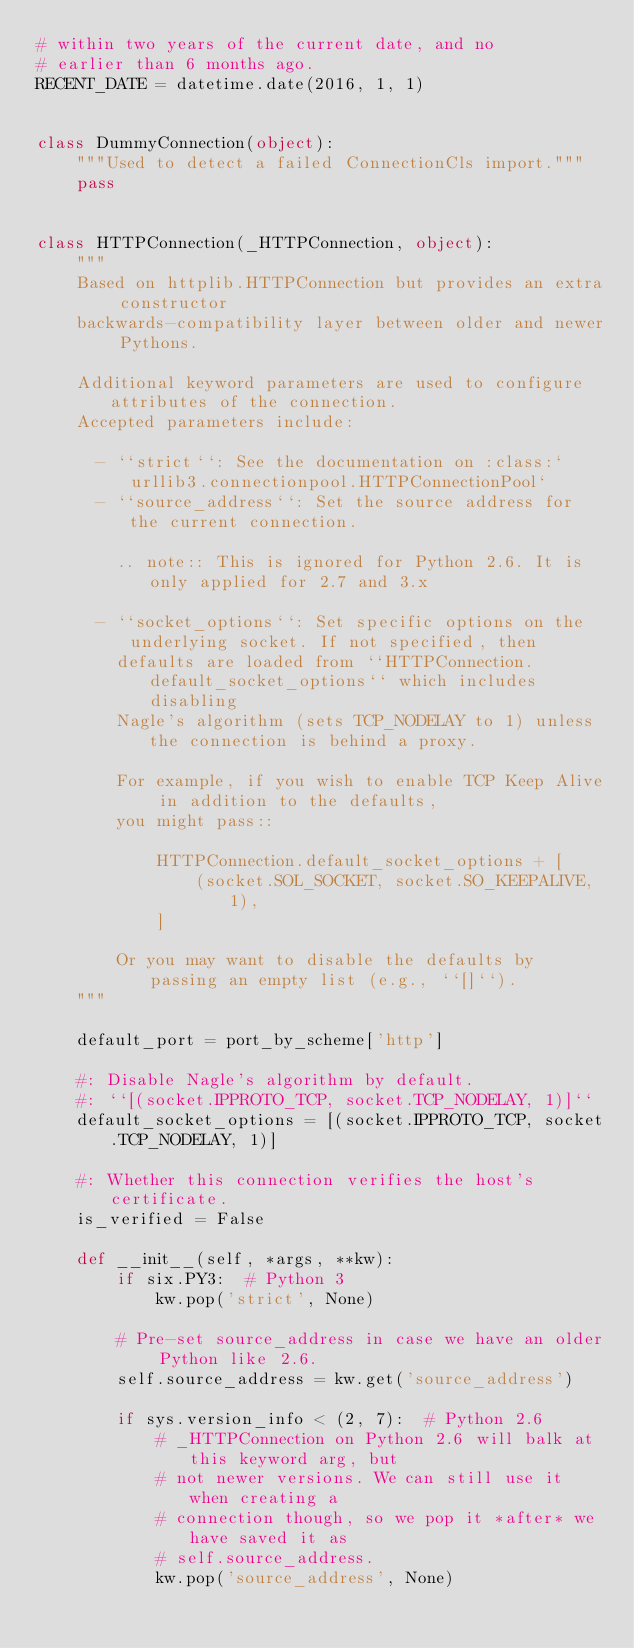Convert code to text. <code><loc_0><loc_0><loc_500><loc_500><_Python_># within two years of the current date, and no
# earlier than 6 months ago.
RECENT_DATE = datetime.date(2016, 1, 1)


class DummyConnection(object):
    """Used to detect a failed ConnectionCls import."""
    pass


class HTTPConnection(_HTTPConnection, object):
    """
    Based on httplib.HTTPConnection but provides an extra constructor
    backwards-compatibility layer between older and newer Pythons.

    Additional keyword parameters are used to configure attributes of the connection.
    Accepted parameters include:

      - ``strict``: See the documentation on :class:`urllib3.connectionpool.HTTPConnectionPool`
      - ``source_address``: Set the source address for the current connection.

        .. note:: This is ignored for Python 2.6. It is only applied for 2.7 and 3.x

      - ``socket_options``: Set specific options on the underlying socket. If not specified, then
        defaults are loaded from ``HTTPConnection.default_socket_options`` which includes disabling
        Nagle's algorithm (sets TCP_NODELAY to 1) unless the connection is behind a proxy.

        For example, if you wish to enable TCP Keep Alive in addition to the defaults,
        you might pass::

            HTTPConnection.default_socket_options + [
                (socket.SOL_SOCKET, socket.SO_KEEPALIVE, 1),
            ]

        Or you may want to disable the defaults by passing an empty list (e.g., ``[]``).
    """

    default_port = port_by_scheme['http']

    #: Disable Nagle's algorithm by default.
    #: ``[(socket.IPPROTO_TCP, socket.TCP_NODELAY, 1)]``
    default_socket_options = [(socket.IPPROTO_TCP, socket.TCP_NODELAY, 1)]

    #: Whether this connection verifies the host's certificate.
    is_verified = False

    def __init__(self, *args, **kw):
        if six.PY3:  # Python 3
            kw.pop('strict', None)

        # Pre-set source_address in case we have an older Python like 2.6.
        self.source_address = kw.get('source_address')

        if sys.version_info < (2, 7):  # Python 2.6
            # _HTTPConnection on Python 2.6 will balk at this keyword arg, but
            # not newer versions. We can still use it when creating a
            # connection though, so we pop it *after* we have saved it as
            # self.source_address.
            kw.pop('source_address', None)
</code> 